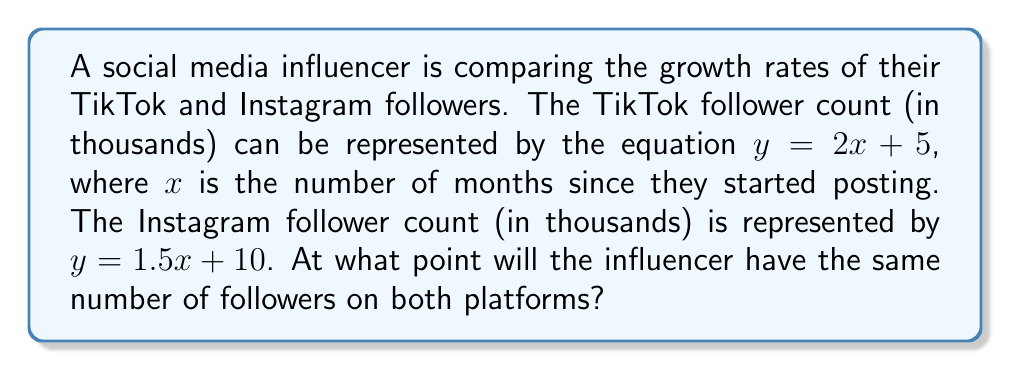Help me with this question. To find the intersection point of these two lines, we need to solve the system of equations:

$$\begin{cases}
y = 2x + 5 \quad \text{(TikTok)}\\
y = 1.5x + 10 \quad \text{(Instagram)}
\end{cases}$$

Step 1: Set the equations equal to each other since we're looking for the point where the y-values (follower counts) are the same.

$2x + 5 = 1.5x + 10$

Step 2: Subtract 1.5x from both sides.

$0.5x + 5 = 10$

Step 3: Subtract 5 from both sides.

$0.5x = 5$

Step 4: Multiply both sides by 2 to isolate x.

$x = 10$

Step 5: Substitute this x-value into either of the original equations to find y. Let's use the TikTok equation:

$y = 2(10) + 5 = 20 + 5 = 25$

Therefore, the intersection point is (10, 25). This means after 10 months, both platforms will have 25,000 followers.
Answer: (10, 25) 